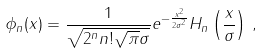<formula> <loc_0><loc_0><loc_500><loc_500>\phi _ { n } ( x ) = \frac { 1 } { \sqrt { 2 ^ { n } n ! \sqrt { \pi } \sigma } } e ^ { - \frac { x ^ { 2 } } { 2 \sigma ^ { 2 } } } H _ { n } \left ( \frac { x } { \sigma } \right ) \, ,</formula> 